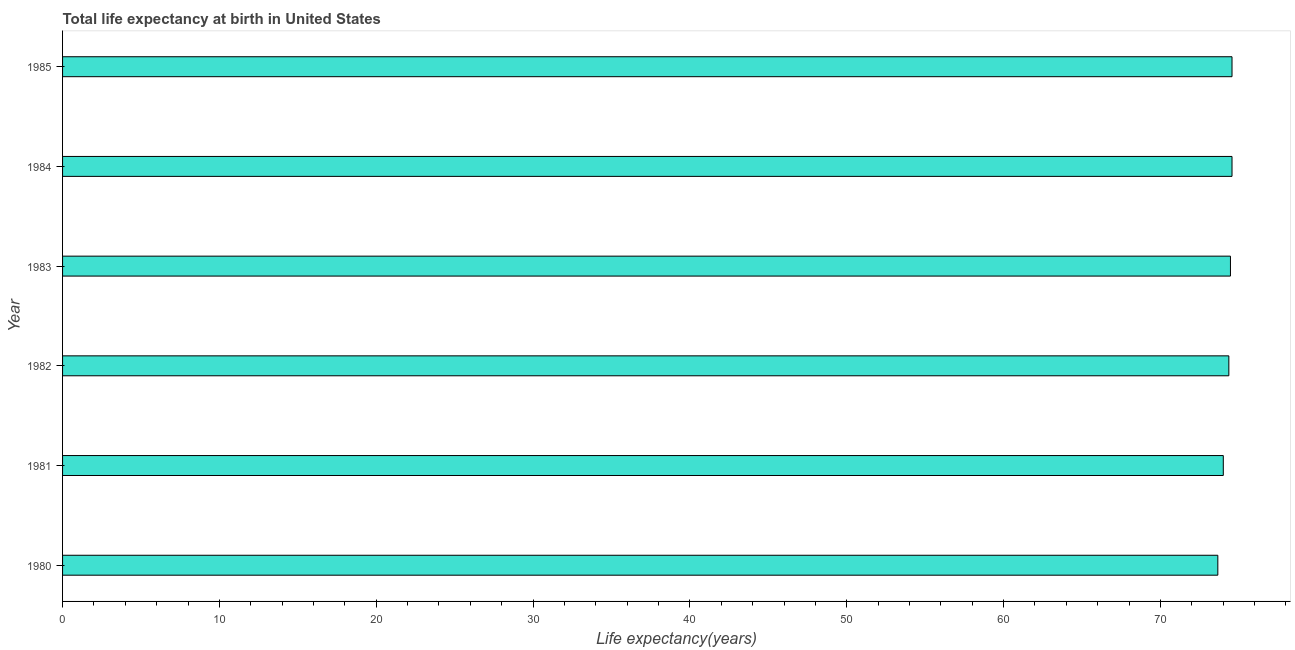Does the graph contain any zero values?
Your response must be concise. No. What is the title of the graph?
Keep it short and to the point. Total life expectancy at birth in United States. What is the label or title of the X-axis?
Provide a short and direct response. Life expectancy(years). What is the life expectancy at birth in 1980?
Your answer should be compact. 73.66. Across all years, what is the maximum life expectancy at birth?
Your answer should be compact. 74.56. Across all years, what is the minimum life expectancy at birth?
Give a very brief answer. 73.66. In which year was the life expectancy at birth maximum?
Give a very brief answer. 1984. In which year was the life expectancy at birth minimum?
Keep it short and to the point. 1980. What is the sum of the life expectancy at birth?
Keep it short and to the point. 445.62. What is the difference between the life expectancy at birth in 1981 and 1982?
Your answer should be very brief. -0.35. What is the average life expectancy at birth per year?
Your answer should be very brief. 74.27. What is the median life expectancy at birth?
Give a very brief answer. 74.41. In how many years, is the life expectancy at birth greater than 76 years?
Your answer should be compact. 0. Do a majority of the years between 1984 and 1983 (inclusive) have life expectancy at birth greater than 64 years?
Your answer should be compact. No. Is the life expectancy at birth in 1984 less than that in 1985?
Your response must be concise. No. Is the difference between the life expectancy at birth in 1981 and 1983 greater than the difference between any two years?
Keep it short and to the point. No. What is the difference between the highest and the second highest life expectancy at birth?
Provide a succinct answer. 0. Is the sum of the life expectancy at birth in 1983 and 1984 greater than the maximum life expectancy at birth across all years?
Ensure brevity in your answer.  Yes. In how many years, is the life expectancy at birth greater than the average life expectancy at birth taken over all years?
Offer a terse response. 4. How many years are there in the graph?
Your answer should be compact. 6. Are the values on the major ticks of X-axis written in scientific E-notation?
Provide a short and direct response. No. What is the Life expectancy(years) of 1980?
Provide a short and direct response. 73.66. What is the Life expectancy(years) of 1981?
Your answer should be compact. 74.01. What is the Life expectancy(years) of 1982?
Keep it short and to the point. 74.36. What is the Life expectancy(years) in 1983?
Give a very brief answer. 74.46. What is the Life expectancy(years) in 1984?
Your response must be concise. 74.56. What is the Life expectancy(years) of 1985?
Ensure brevity in your answer.  74.56. What is the difference between the Life expectancy(years) in 1980 and 1981?
Keep it short and to the point. -0.35. What is the difference between the Life expectancy(years) in 1980 and 1982?
Make the answer very short. -0.7. What is the difference between the Life expectancy(years) in 1980 and 1983?
Provide a succinct answer. -0.8. What is the difference between the Life expectancy(years) in 1980 and 1984?
Offer a very short reply. -0.9. What is the difference between the Life expectancy(years) in 1980 and 1985?
Provide a succinct answer. -0.9. What is the difference between the Life expectancy(years) in 1981 and 1982?
Ensure brevity in your answer.  -0.35. What is the difference between the Life expectancy(years) in 1981 and 1983?
Give a very brief answer. -0.46. What is the difference between the Life expectancy(years) in 1981 and 1984?
Keep it short and to the point. -0.56. What is the difference between the Life expectancy(years) in 1981 and 1985?
Ensure brevity in your answer.  -0.56. What is the difference between the Life expectancy(years) in 1982 and 1983?
Your answer should be very brief. -0.1. What is the difference between the Life expectancy(years) in 1982 and 1984?
Offer a very short reply. -0.2. What is the difference between the Life expectancy(years) in 1982 and 1985?
Your answer should be compact. -0.2. What is the difference between the Life expectancy(years) in 1983 and 1984?
Offer a very short reply. -0.1. What is the difference between the Life expectancy(years) in 1984 and 1985?
Your answer should be very brief. 0. What is the ratio of the Life expectancy(years) in 1980 to that in 1982?
Offer a very short reply. 0.99. What is the ratio of the Life expectancy(years) in 1980 to that in 1983?
Give a very brief answer. 0.99. What is the ratio of the Life expectancy(years) in 1981 to that in 1983?
Keep it short and to the point. 0.99. What is the ratio of the Life expectancy(years) in 1981 to that in 1985?
Offer a terse response. 0.99. What is the ratio of the Life expectancy(years) in 1982 to that in 1984?
Ensure brevity in your answer.  1. What is the ratio of the Life expectancy(years) in 1983 to that in 1984?
Your answer should be very brief. 1. What is the ratio of the Life expectancy(years) in 1983 to that in 1985?
Offer a terse response. 1. What is the ratio of the Life expectancy(years) in 1984 to that in 1985?
Ensure brevity in your answer.  1. 